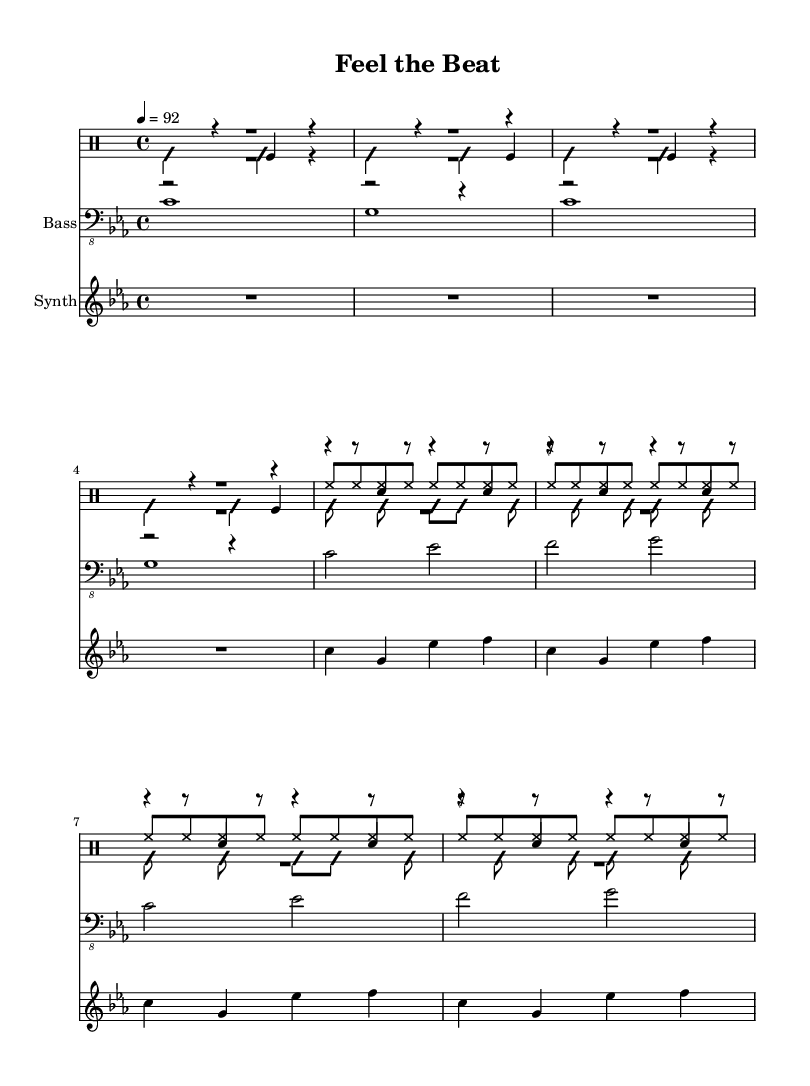What is the key signature of this music? The key signature is indicated by the absence of any sharps or flats in the beginning, which means it is C minor with three flats.
Answer: C minor What is the time signature of this music? The time signature is located at the beginning of the sheet music, shown as "4/4", which indicates four beats in a measure.
Answer: 4/4 What is the tempo marking for this piece? The tempo marking appears at the beginning, indicated by "4 = 92", signifying the speed of the piece.
Answer: 92 How many measures are in the intro section? By counting the measures in the part labeled "Intro," there are a total of 8 measures presented before the verse begins.
Answer: 8 What type of musical instruments are used in this rap music piece? The instruments shown are a drum set, a bass guitar, and a synthesizer, indicating the combination typical in rap music.
Answer: Drum set, bass guitar, synthesizer What is the primary rhythmic focus in this rap music? The primary rhythmic focus can be observed in the drum patterns which provide strong beats and vibrations that characterize rap music.
Answer: Strong beats What does the "bd" notation refer to in the drum part? The "bd" notation in the drum part specifies the bass drum, which is commonly used to create a deep sound and rhythmic foundation in rap.
Answer: Bass drum 